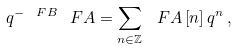<formula> <loc_0><loc_0><loc_500><loc_500>q ^ { - \ F B } \ F A = \sum _ { n \in \mathbb { Z } } \ F A \left [ n \right ] q ^ { n } \, ,</formula> 